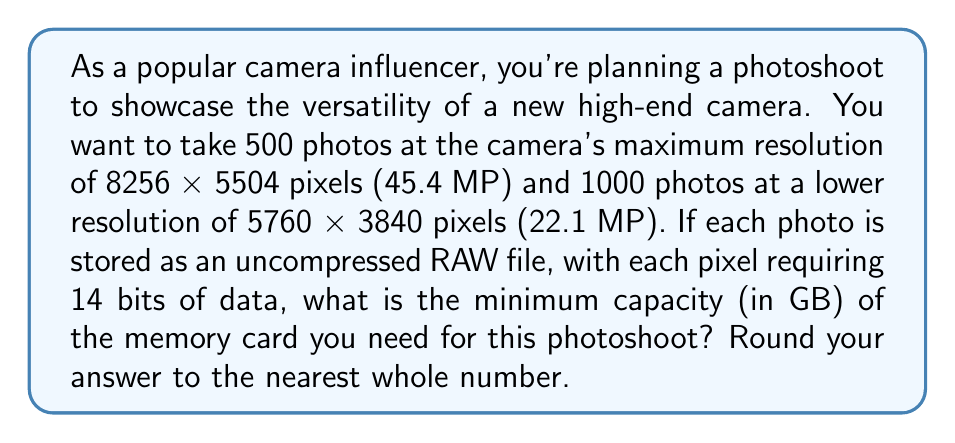Could you help me with this problem? Let's break this down step-by-step:

1) First, we need to calculate the number of bits required for each photo at each resolution:

   For 45.4 MP photos:
   $$ 8256 \times 5504 \times 14 = 636,141,568 \text{ bits} $$

   For 22.1 MP photos:
   $$ 5760 \times 3840 \times 14 = 309,657,600 \text{ bits} $$

2) Now, let's calculate the total number of bits for all photos:

   $$ (500 \times 636,141,568) + (1000 \times 309,657,600) = 318,070,784,000 + 309,657,600,000 = 627,728,384,000 \text{ bits} $$

3) To convert bits to bytes, we divide by 8:

   $$ 627,728,384,000 \div 8 = 78,466,048,000 \text{ bytes} $$

4) To convert bytes to gigabytes, we divide by $1024^3$ (since 1 GB = 1024 MB = 1024 * 1024 KB = 1024 * 1024 * 1024 bytes):

   $$ 78,466,048,000 \div (1024^3) \approx 73.08 \text{ GB} $$

5) Rounding to the nearest whole number:

   $$ 73.08 \text{ GB} \approx 73 \text{ GB} $$

Therefore, you need a memory card with a minimum capacity of 73 GB for this photoshoot.
Answer: 73 GB 